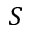Convert formula to latex. <formula><loc_0><loc_0><loc_500><loc_500>S</formula> 